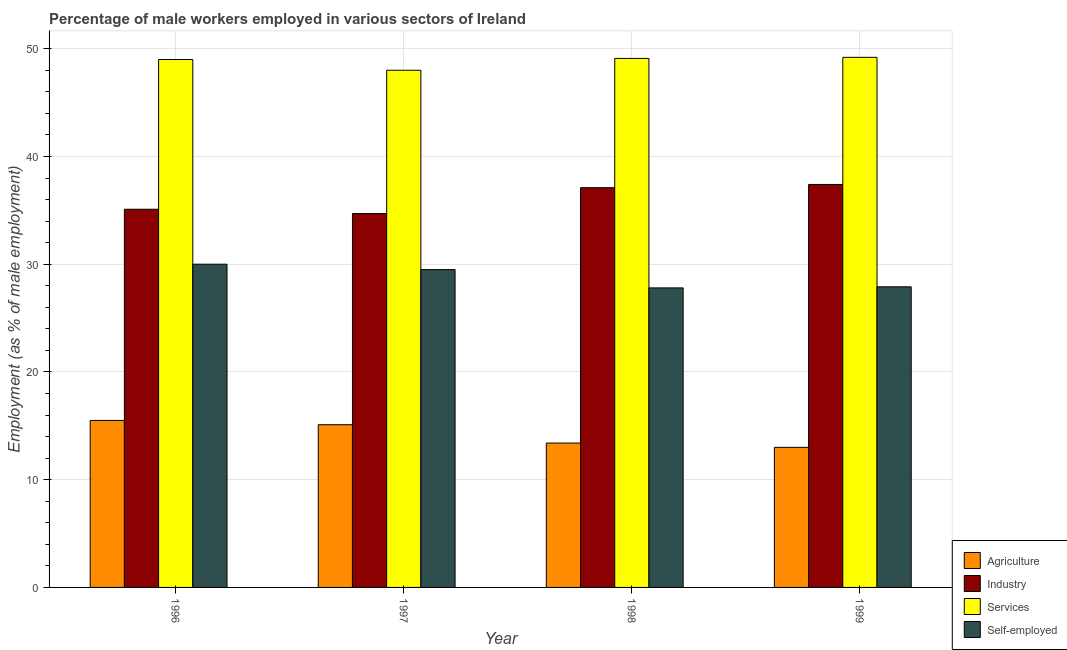How many different coloured bars are there?
Make the answer very short. 4. Are the number of bars per tick equal to the number of legend labels?
Provide a succinct answer. Yes. Are the number of bars on each tick of the X-axis equal?
Ensure brevity in your answer.  Yes. How many bars are there on the 3rd tick from the left?
Make the answer very short. 4. What is the percentage of male workers in industry in 1999?
Give a very brief answer. 37.4. Across all years, what is the minimum percentage of male workers in industry?
Give a very brief answer. 34.7. What is the total percentage of male workers in services in the graph?
Give a very brief answer. 195.3. What is the difference between the percentage of male workers in industry in 1996 and that in 1999?
Give a very brief answer. -2.3. What is the difference between the percentage of male workers in industry in 1997 and the percentage of self employed male workers in 1999?
Make the answer very short. -2.7. What is the average percentage of male workers in industry per year?
Your answer should be compact. 36.07. In how many years, is the percentage of self employed male workers greater than 34 %?
Provide a short and direct response. 0. What is the ratio of the percentage of male workers in industry in 1997 to that in 1998?
Your answer should be very brief. 0.94. What is the difference between the highest and the lowest percentage of male workers in services?
Your answer should be compact. 1.2. What does the 3rd bar from the left in 1997 represents?
Keep it short and to the point. Services. What does the 2nd bar from the right in 1996 represents?
Give a very brief answer. Services. How many bars are there?
Ensure brevity in your answer.  16. Are all the bars in the graph horizontal?
Your answer should be compact. No. How many years are there in the graph?
Your answer should be compact. 4. What is the difference between two consecutive major ticks on the Y-axis?
Provide a short and direct response. 10. Does the graph contain any zero values?
Your answer should be very brief. No. Does the graph contain grids?
Ensure brevity in your answer.  Yes. Where does the legend appear in the graph?
Your answer should be very brief. Bottom right. How many legend labels are there?
Ensure brevity in your answer.  4. How are the legend labels stacked?
Provide a short and direct response. Vertical. What is the title of the graph?
Provide a succinct answer. Percentage of male workers employed in various sectors of Ireland. What is the label or title of the Y-axis?
Make the answer very short. Employment (as % of male employment). What is the Employment (as % of male employment) of Industry in 1996?
Ensure brevity in your answer.  35.1. What is the Employment (as % of male employment) in Self-employed in 1996?
Offer a very short reply. 30. What is the Employment (as % of male employment) of Agriculture in 1997?
Your answer should be compact. 15.1. What is the Employment (as % of male employment) in Industry in 1997?
Make the answer very short. 34.7. What is the Employment (as % of male employment) of Self-employed in 1997?
Make the answer very short. 29.5. What is the Employment (as % of male employment) of Agriculture in 1998?
Your response must be concise. 13.4. What is the Employment (as % of male employment) of Industry in 1998?
Give a very brief answer. 37.1. What is the Employment (as % of male employment) of Services in 1998?
Your response must be concise. 49.1. What is the Employment (as % of male employment) in Self-employed in 1998?
Your answer should be very brief. 27.8. What is the Employment (as % of male employment) of Industry in 1999?
Your response must be concise. 37.4. What is the Employment (as % of male employment) of Services in 1999?
Keep it short and to the point. 49.2. What is the Employment (as % of male employment) of Self-employed in 1999?
Make the answer very short. 27.9. Across all years, what is the maximum Employment (as % of male employment) in Agriculture?
Offer a terse response. 15.5. Across all years, what is the maximum Employment (as % of male employment) of Industry?
Provide a short and direct response. 37.4. Across all years, what is the maximum Employment (as % of male employment) of Services?
Your answer should be very brief. 49.2. Across all years, what is the minimum Employment (as % of male employment) of Agriculture?
Ensure brevity in your answer.  13. Across all years, what is the minimum Employment (as % of male employment) of Industry?
Provide a short and direct response. 34.7. Across all years, what is the minimum Employment (as % of male employment) in Self-employed?
Your response must be concise. 27.8. What is the total Employment (as % of male employment) of Agriculture in the graph?
Offer a very short reply. 57. What is the total Employment (as % of male employment) of Industry in the graph?
Provide a short and direct response. 144.3. What is the total Employment (as % of male employment) of Services in the graph?
Offer a very short reply. 195.3. What is the total Employment (as % of male employment) of Self-employed in the graph?
Offer a very short reply. 115.2. What is the difference between the Employment (as % of male employment) in Agriculture in 1996 and that in 1997?
Offer a terse response. 0.4. What is the difference between the Employment (as % of male employment) in Industry in 1996 and that in 1997?
Provide a succinct answer. 0.4. What is the difference between the Employment (as % of male employment) of Services in 1996 and that in 1997?
Your response must be concise. 1. What is the difference between the Employment (as % of male employment) of Self-employed in 1996 and that in 1997?
Offer a very short reply. 0.5. What is the difference between the Employment (as % of male employment) in Self-employed in 1996 and that in 1998?
Make the answer very short. 2.2. What is the difference between the Employment (as % of male employment) in Agriculture in 1996 and that in 1999?
Keep it short and to the point. 2.5. What is the difference between the Employment (as % of male employment) of Self-employed in 1996 and that in 1999?
Give a very brief answer. 2.1. What is the difference between the Employment (as % of male employment) of Services in 1997 and that in 1998?
Your response must be concise. -1.1. What is the difference between the Employment (as % of male employment) in Industry in 1997 and that in 1999?
Provide a succinct answer. -2.7. What is the difference between the Employment (as % of male employment) of Services in 1997 and that in 1999?
Ensure brevity in your answer.  -1.2. What is the difference between the Employment (as % of male employment) of Self-employed in 1997 and that in 1999?
Keep it short and to the point. 1.6. What is the difference between the Employment (as % of male employment) of Industry in 1998 and that in 1999?
Keep it short and to the point. -0.3. What is the difference between the Employment (as % of male employment) in Agriculture in 1996 and the Employment (as % of male employment) in Industry in 1997?
Make the answer very short. -19.2. What is the difference between the Employment (as % of male employment) in Agriculture in 1996 and the Employment (as % of male employment) in Services in 1997?
Give a very brief answer. -32.5. What is the difference between the Employment (as % of male employment) of Industry in 1996 and the Employment (as % of male employment) of Self-employed in 1997?
Offer a very short reply. 5.6. What is the difference between the Employment (as % of male employment) of Services in 1996 and the Employment (as % of male employment) of Self-employed in 1997?
Your answer should be compact. 19.5. What is the difference between the Employment (as % of male employment) in Agriculture in 1996 and the Employment (as % of male employment) in Industry in 1998?
Your answer should be very brief. -21.6. What is the difference between the Employment (as % of male employment) in Agriculture in 1996 and the Employment (as % of male employment) in Services in 1998?
Provide a short and direct response. -33.6. What is the difference between the Employment (as % of male employment) of Agriculture in 1996 and the Employment (as % of male employment) of Self-employed in 1998?
Ensure brevity in your answer.  -12.3. What is the difference between the Employment (as % of male employment) in Industry in 1996 and the Employment (as % of male employment) in Services in 1998?
Your answer should be compact. -14. What is the difference between the Employment (as % of male employment) of Services in 1996 and the Employment (as % of male employment) of Self-employed in 1998?
Your response must be concise. 21.2. What is the difference between the Employment (as % of male employment) of Agriculture in 1996 and the Employment (as % of male employment) of Industry in 1999?
Your answer should be compact. -21.9. What is the difference between the Employment (as % of male employment) of Agriculture in 1996 and the Employment (as % of male employment) of Services in 1999?
Make the answer very short. -33.7. What is the difference between the Employment (as % of male employment) in Industry in 1996 and the Employment (as % of male employment) in Services in 1999?
Your response must be concise. -14.1. What is the difference between the Employment (as % of male employment) of Industry in 1996 and the Employment (as % of male employment) of Self-employed in 1999?
Keep it short and to the point. 7.2. What is the difference between the Employment (as % of male employment) in Services in 1996 and the Employment (as % of male employment) in Self-employed in 1999?
Ensure brevity in your answer.  21.1. What is the difference between the Employment (as % of male employment) of Agriculture in 1997 and the Employment (as % of male employment) of Services in 1998?
Give a very brief answer. -34. What is the difference between the Employment (as % of male employment) of Industry in 1997 and the Employment (as % of male employment) of Services in 1998?
Keep it short and to the point. -14.4. What is the difference between the Employment (as % of male employment) in Services in 1997 and the Employment (as % of male employment) in Self-employed in 1998?
Make the answer very short. 20.2. What is the difference between the Employment (as % of male employment) of Agriculture in 1997 and the Employment (as % of male employment) of Industry in 1999?
Your response must be concise. -22.3. What is the difference between the Employment (as % of male employment) in Agriculture in 1997 and the Employment (as % of male employment) in Services in 1999?
Your answer should be compact. -34.1. What is the difference between the Employment (as % of male employment) of Agriculture in 1997 and the Employment (as % of male employment) of Self-employed in 1999?
Offer a very short reply. -12.8. What is the difference between the Employment (as % of male employment) of Industry in 1997 and the Employment (as % of male employment) of Self-employed in 1999?
Provide a succinct answer. 6.8. What is the difference between the Employment (as % of male employment) of Services in 1997 and the Employment (as % of male employment) of Self-employed in 1999?
Offer a very short reply. 20.1. What is the difference between the Employment (as % of male employment) in Agriculture in 1998 and the Employment (as % of male employment) in Services in 1999?
Offer a terse response. -35.8. What is the difference between the Employment (as % of male employment) of Services in 1998 and the Employment (as % of male employment) of Self-employed in 1999?
Provide a succinct answer. 21.2. What is the average Employment (as % of male employment) in Agriculture per year?
Offer a very short reply. 14.25. What is the average Employment (as % of male employment) in Industry per year?
Your response must be concise. 36.08. What is the average Employment (as % of male employment) of Services per year?
Make the answer very short. 48.83. What is the average Employment (as % of male employment) of Self-employed per year?
Give a very brief answer. 28.8. In the year 1996, what is the difference between the Employment (as % of male employment) of Agriculture and Employment (as % of male employment) of Industry?
Your answer should be very brief. -19.6. In the year 1996, what is the difference between the Employment (as % of male employment) in Agriculture and Employment (as % of male employment) in Services?
Your answer should be very brief. -33.5. In the year 1996, what is the difference between the Employment (as % of male employment) of Agriculture and Employment (as % of male employment) of Self-employed?
Offer a terse response. -14.5. In the year 1996, what is the difference between the Employment (as % of male employment) of Industry and Employment (as % of male employment) of Services?
Your answer should be compact. -13.9. In the year 1996, what is the difference between the Employment (as % of male employment) of Industry and Employment (as % of male employment) of Self-employed?
Your response must be concise. 5.1. In the year 1997, what is the difference between the Employment (as % of male employment) of Agriculture and Employment (as % of male employment) of Industry?
Your answer should be very brief. -19.6. In the year 1997, what is the difference between the Employment (as % of male employment) in Agriculture and Employment (as % of male employment) in Services?
Give a very brief answer. -32.9. In the year 1997, what is the difference between the Employment (as % of male employment) in Agriculture and Employment (as % of male employment) in Self-employed?
Your answer should be compact. -14.4. In the year 1997, what is the difference between the Employment (as % of male employment) of Industry and Employment (as % of male employment) of Services?
Your answer should be very brief. -13.3. In the year 1998, what is the difference between the Employment (as % of male employment) of Agriculture and Employment (as % of male employment) of Industry?
Give a very brief answer. -23.7. In the year 1998, what is the difference between the Employment (as % of male employment) of Agriculture and Employment (as % of male employment) of Services?
Your response must be concise. -35.7. In the year 1998, what is the difference between the Employment (as % of male employment) in Agriculture and Employment (as % of male employment) in Self-employed?
Your response must be concise. -14.4. In the year 1998, what is the difference between the Employment (as % of male employment) in Services and Employment (as % of male employment) in Self-employed?
Make the answer very short. 21.3. In the year 1999, what is the difference between the Employment (as % of male employment) in Agriculture and Employment (as % of male employment) in Industry?
Provide a succinct answer. -24.4. In the year 1999, what is the difference between the Employment (as % of male employment) of Agriculture and Employment (as % of male employment) of Services?
Keep it short and to the point. -36.2. In the year 1999, what is the difference between the Employment (as % of male employment) in Agriculture and Employment (as % of male employment) in Self-employed?
Your answer should be compact. -14.9. In the year 1999, what is the difference between the Employment (as % of male employment) in Industry and Employment (as % of male employment) in Services?
Offer a terse response. -11.8. In the year 1999, what is the difference between the Employment (as % of male employment) of Industry and Employment (as % of male employment) of Self-employed?
Your response must be concise. 9.5. In the year 1999, what is the difference between the Employment (as % of male employment) in Services and Employment (as % of male employment) in Self-employed?
Your answer should be very brief. 21.3. What is the ratio of the Employment (as % of male employment) in Agriculture in 1996 to that in 1997?
Offer a terse response. 1.03. What is the ratio of the Employment (as % of male employment) in Industry in 1996 to that in 1997?
Your response must be concise. 1.01. What is the ratio of the Employment (as % of male employment) in Services in 1996 to that in 1997?
Give a very brief answer. 1.02. What is the ratio of the Employment (as % of male employment) in Self-employed in 1996 to that in 1997?
Your response must be concise. 1.02. What is the ratio of the Employment (as % of male employment) of Agriculture in 1996 to that in 1998?
Offer a very short reply. 1.16. What is the ratio of the Employment (as % of male employment) in Industry in 1996 to that in 1998?
Your answer should be compact. 0.95. What is the ratio of the Employment (as % of male employment) of Services in 1996 to that in 1998?
Offer a terse response. 1. What is the ratio of the Employment (as % of male employment) of Self-employed in 1996 to that in 1998?
Your answer should be compact. 1.08. What is the ratio of the Employment (as % of male employment) of Agriculture in 1996 to that in 1999?
Your answer should be very brief. 1.19. What is the ratio of the Employment (as % of male employment) in Industry in 1996 to that in 1999?
Your answer should be compact. 0.94. What is the ratio of the Employment (as % of male employment) of Self-employed in 1996 to that in 1999?
Make the answer very short. 1.08. What is the ratio of the Employment (as % of male employment) of Agriculture in 1997 to that in 1998?
Make the answer very short. 1.13. What is the ratio of the Employment (as % of male employment) of Industry in 1997 to that in 1998?
Keep it short and to the point. 0.94. What is the ratio of the Employment (as % of male employment) in Services in 1997 to that in 1998?
Your response must be concise. 0.98. What is the ratio of the Employment (as % of male employment) in Self-employed in 1997 to that in 1998?
Give a very brief answer. 1.06. What is the ratio of the Employment (as % of male employment) in Agriculture in 1997 to that in 1999?
Offer a very short reply. 1.16. What is the ratio of the Employment (as % of male employment) of Industry in 1997 to that in 1999?
Your answer should be compact. 0.93. What is the ratio of the Employment (as % of male employment) in Services in 1997 to that in 1999?
Keep it short and to the point. 0.98. What is the ratio of the Employment (as % of male employment) of Self-employed in 1997 to that in 1999?
Provide a short and direct response. 1.06. What is the ratio of the Employment (as % of male employment) of Agriculture in 1998 to that in 1999?
Provide a short and direct response. 1.03. What is the ratio of the Employment (as % of male employment) of Services in 1998 to that in 1999?
Keep it short and to the point. 1. What is the ratio of the Employment (as % of male employment) in Self-employed in 1998 to that in 1999?
Offer a very short reply. 1. What is the difference between the highest and the second highest Employment (as % of male employment) in Self-employed?
Your response must be concise. 0.5. 